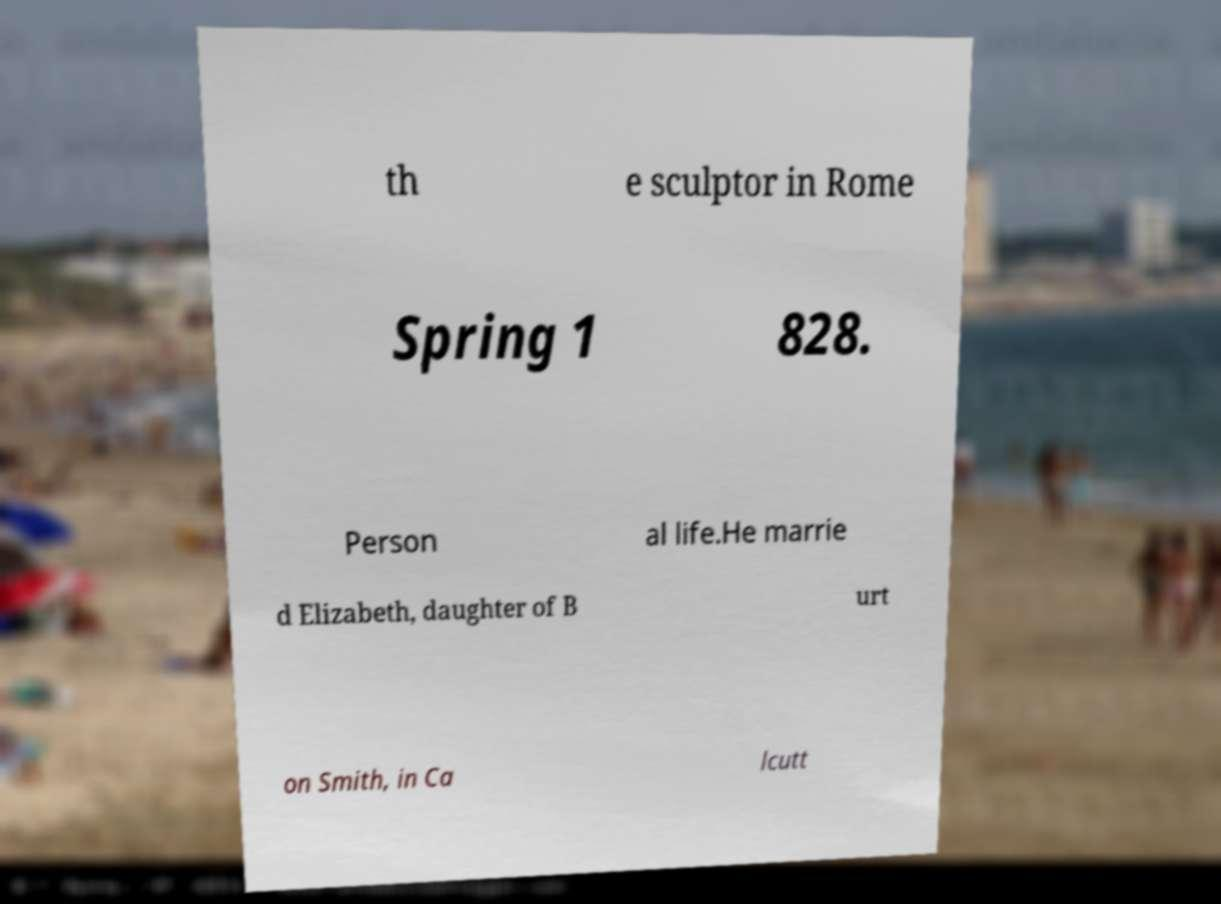What messages or text are displayed in this image? I need them in a readable, typed format. th e sculptor in Rome Spring 1 828. Person al life.He marrie d Elizabeth, daughter of B urt on Smith, in Ca lcutt 